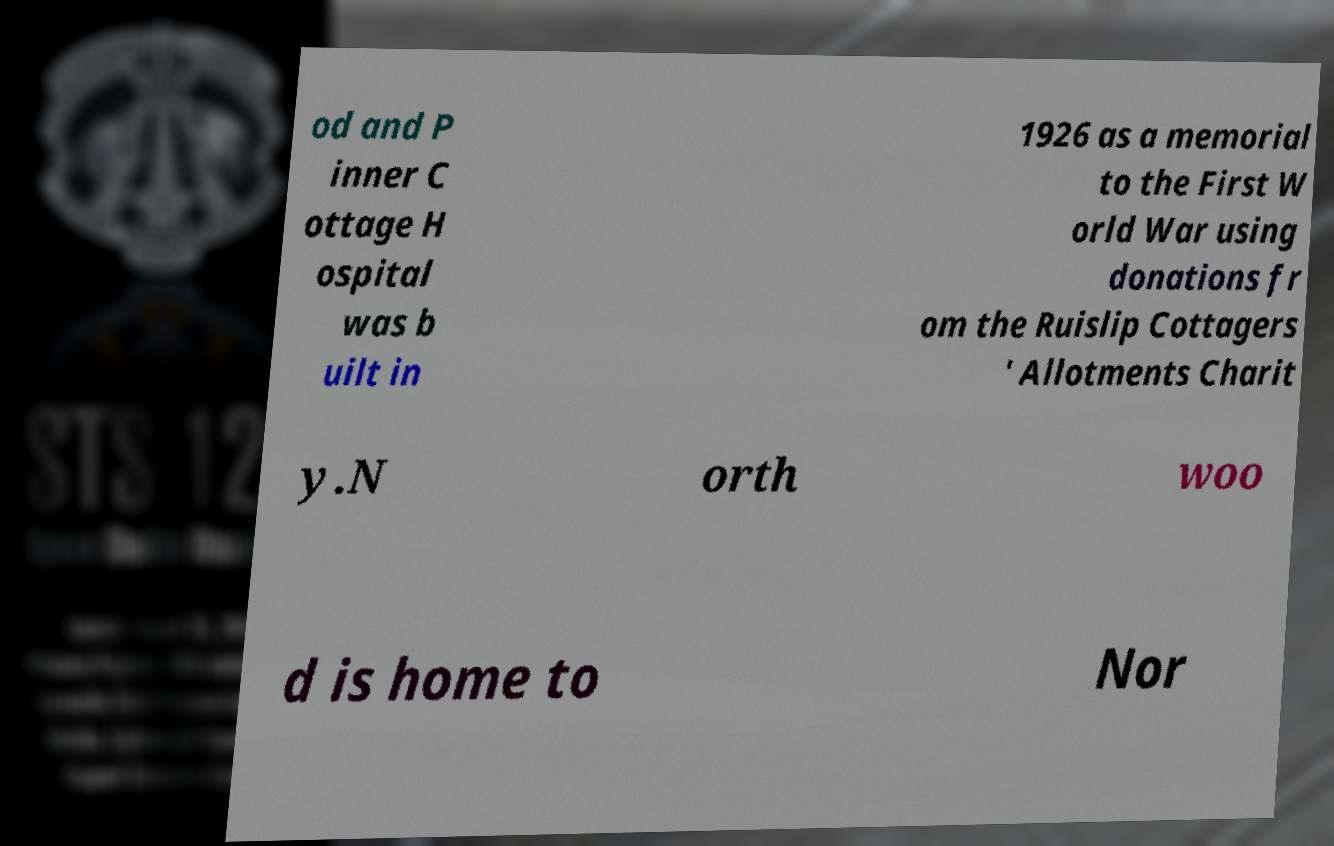Please read and relay the text visible in this image. What does it say? od and P inner C ottage H ospital was b uilt in 1926 as a memorial to the First W orld War using donations fr om the Ruislip Cottagers ' Allotments Charit y.N orth woo d is home to Nor 